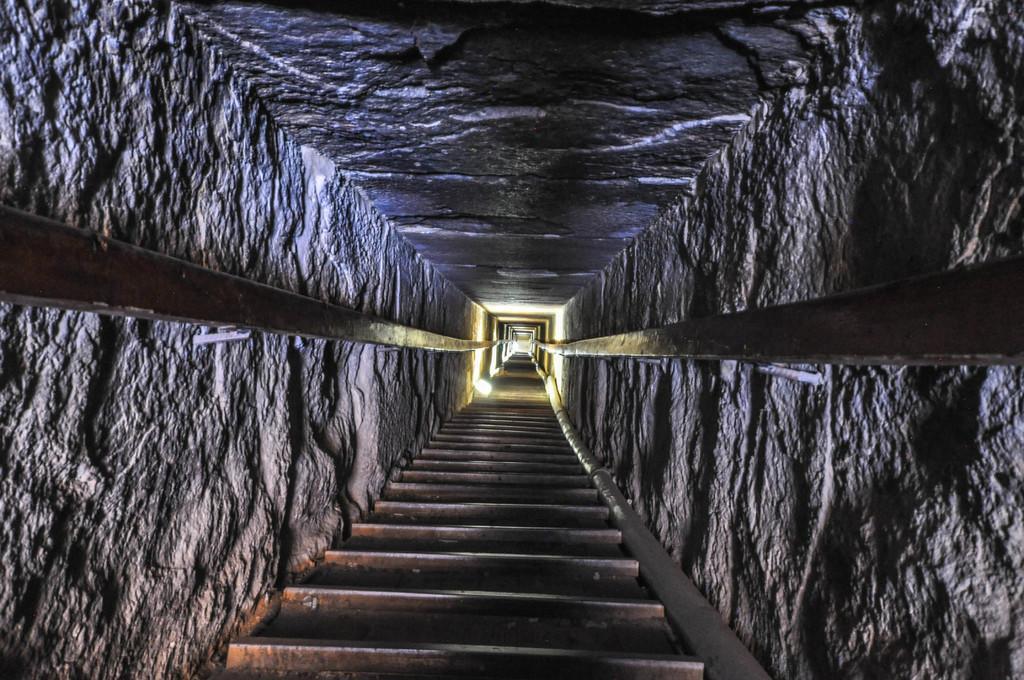Could you give a brief overview of what you see in this image? In this picture, there is a tunnel. At the bottom there are iron bars. Towards the left and right, there are poles attached to the stones. 